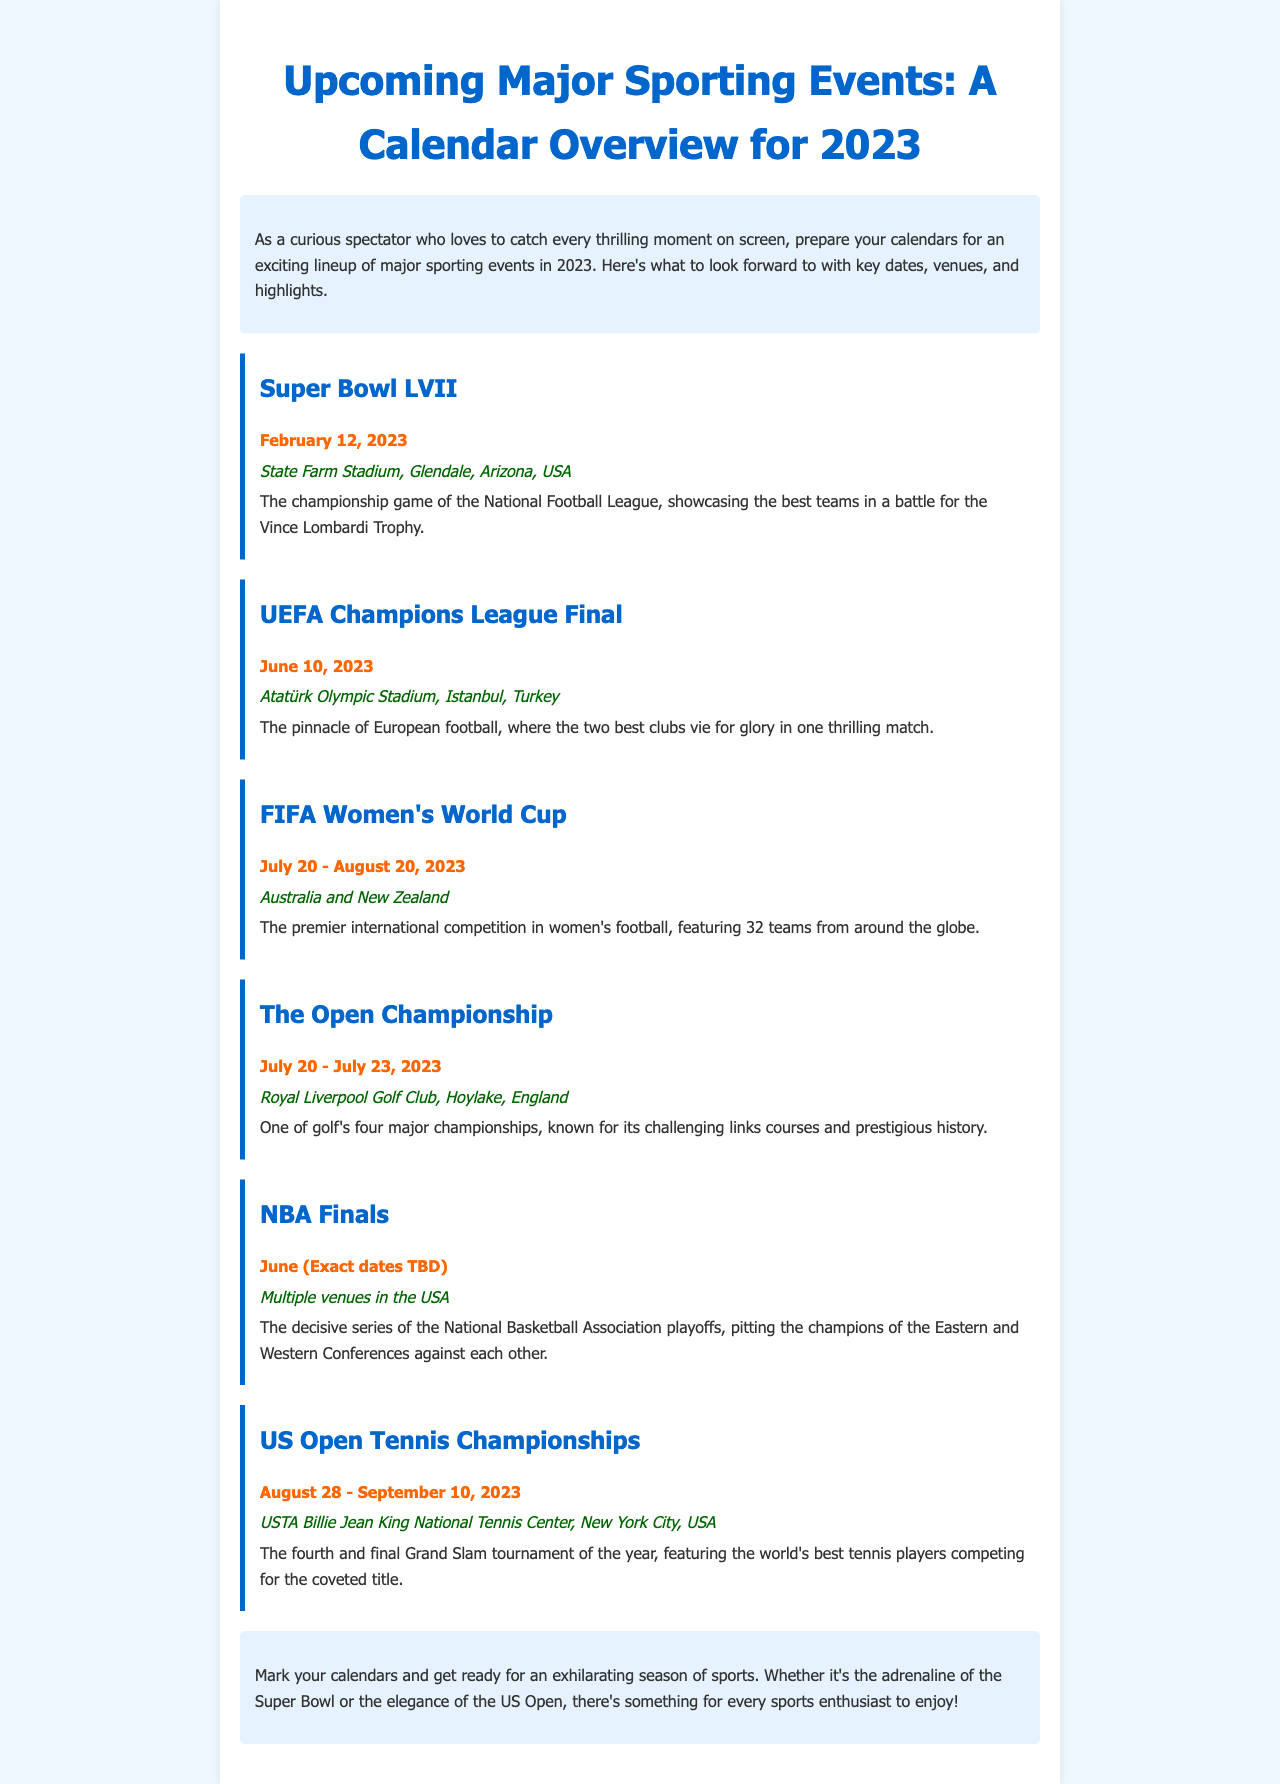What is the date of the Super Bowl LVII? The date of the Super Bowl LVII is specifically stated in the document as February 12, 2023.
Answer: February 12, 2023 Where is the UEFA Champions League Final being held? The venue for the UEFA Champions League Final is explicitly mentioned as Atatürk Olympic Stadium in Istanbul, Turkey.
Answer: Atatürk Olympic Stadium, Istanbul, Turkey How long does the FIFA Women's World Cup span? The document specifies that the FIFA Women's World Cup takes place from July 20 to August 20, 2023, indicating a duration of one month.
Answer: July 20 - August 20, 2023 What major event occurs during the month of June? The document lists the NBA Finals as an event occurring in June, although the exact dates are yet to be determined.
Answer: NBA Finals Which sport is featured at the US Open Tennis Championships? The document clearly indicates that the US Open Tennis Championships is a tennis competition, as stated in the description.
Answer: Tennis 